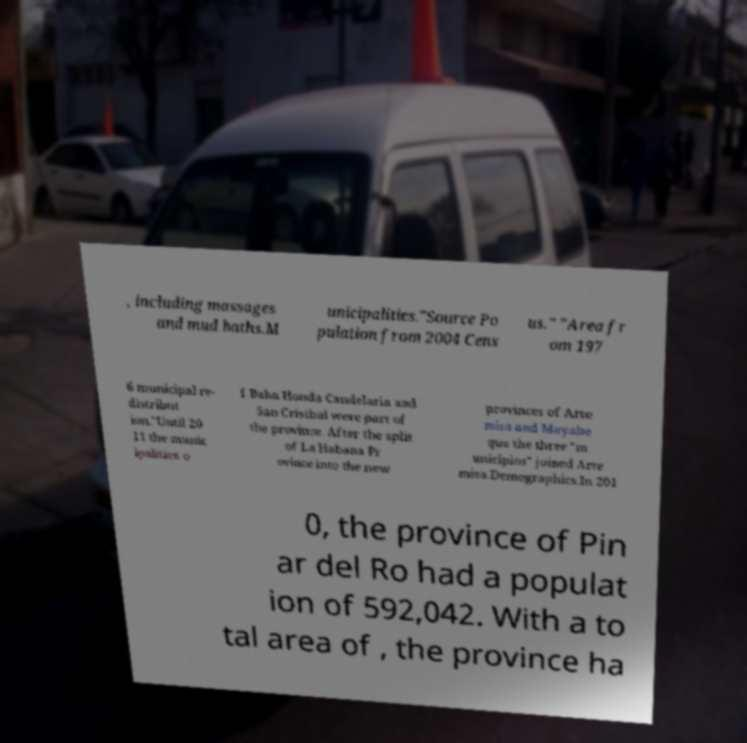Could you extract and type out the text from this image? , including massages and mud baths.M unicipalities."Source Po pulation from 2004 Cens us." "Area fr om 197 6 municipal re- distribut ion."Until 20 11 the munic ipalities o f Baha Honda Candelaria and San Cristbal were part of the province. After the split of La Habana Pr ovince into the new provinces of Arte misa and Mayabe que the three "m unicipios" joined Arte misa.Demographics.In 201 0, the province of Pin ar del Ro had a populat ion of 592,042. With a to tal area of , the province ha 